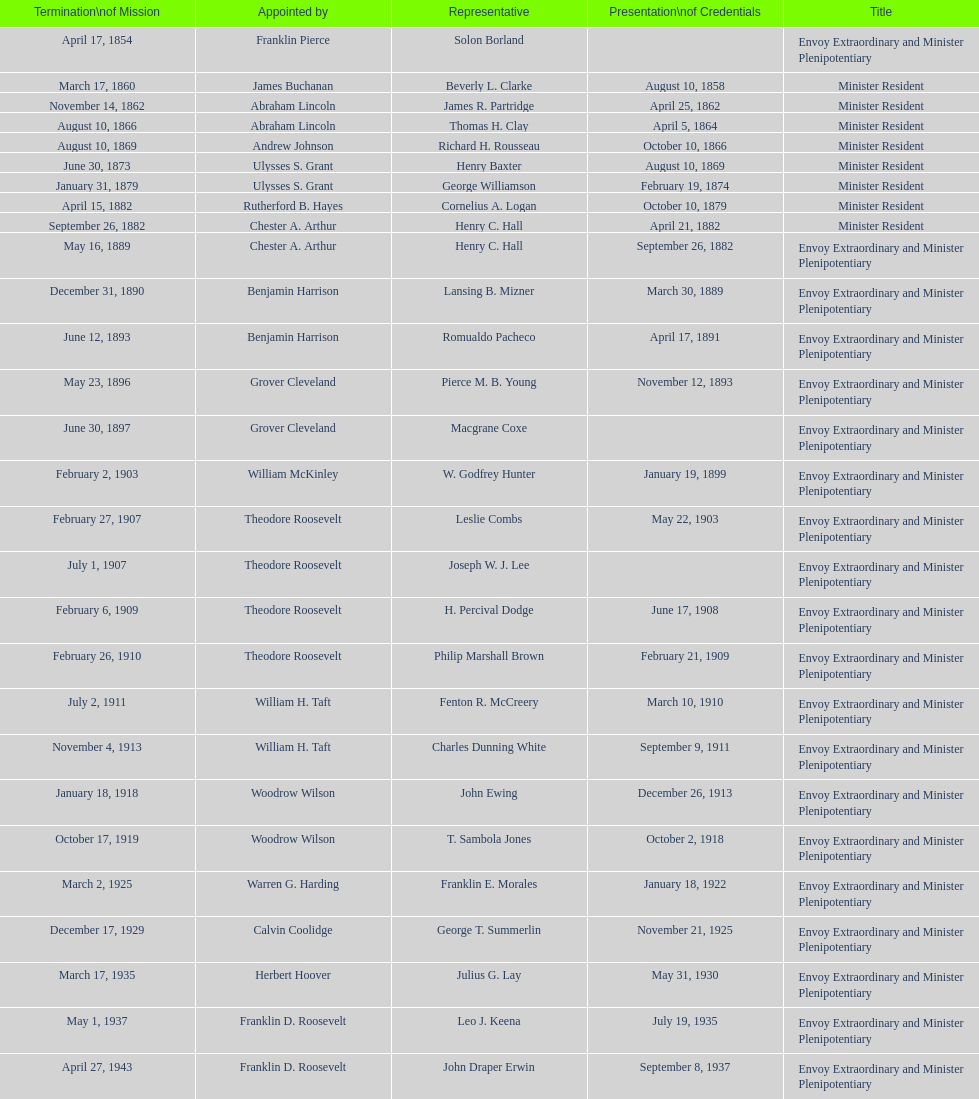Who became the ambassador after the completion of hewson ryan's mission? Phillip V. Sanchez. 